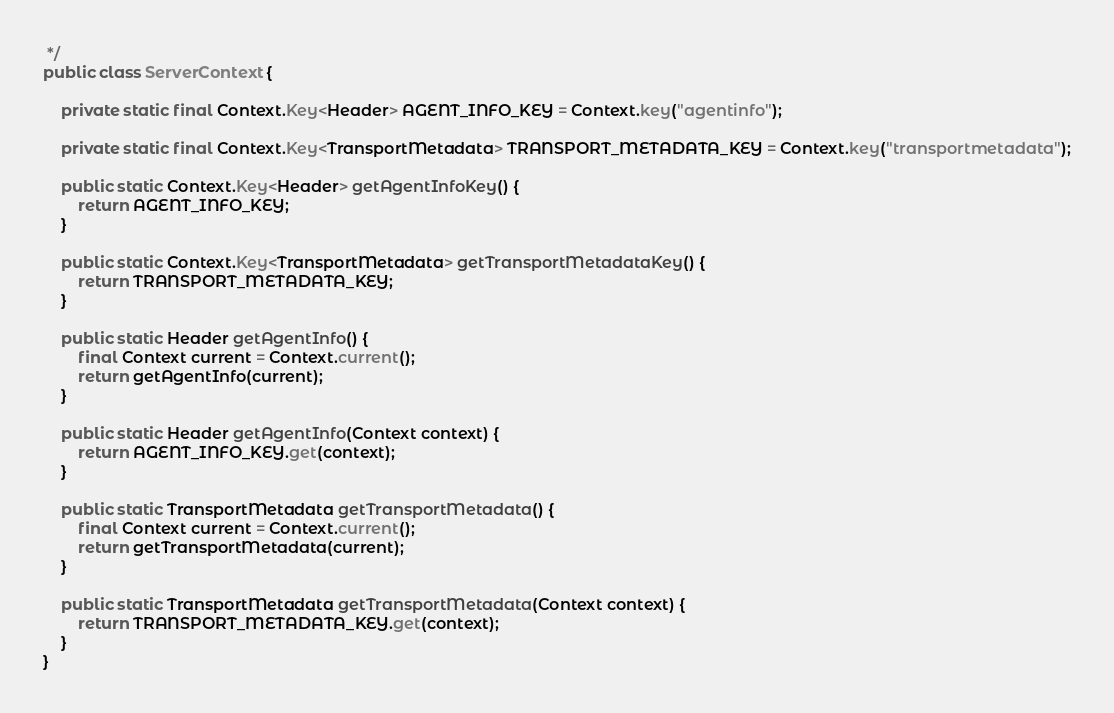Convert code to text. <code><loc_0><loc_0><loc_500><loc_500><_Java_> */
public class ServerContext {

    private static final Context.Key<Header> AGENT_INFO_KEY = Context.key("agentinfo");

    private static final Context.Key<TransportMetadata> TRANSPORT_METADATA_KEY = Context.key("transportmetadata");

    public static Context.Key<Header> getAgentInfoKey() {
        return AGENT_INFO_KEY;
    }

    public static Context.Key<TransportMetadata> getTransportMetadataKey() {
        return TRANSPORT_METADATA_KEY;
    }

    public static Header getAgentInfo() {
        final Context current = Context.current();
        return getAgentInfo(current);
    }

    public static Header getAgentInfo(Context context) {
        return AGENT_INFO_KEY.get(context);
    }

    public static TransportMetadata getTransportMetadata() {
        final Context current = Context.current();
        return getTransportMetadata(current);
    }

    public static TransportMetadata getTransportMetadata(Context context) {
        return TRANSPORT_METADATA_KEY.get(context);
    }
}
</code> 